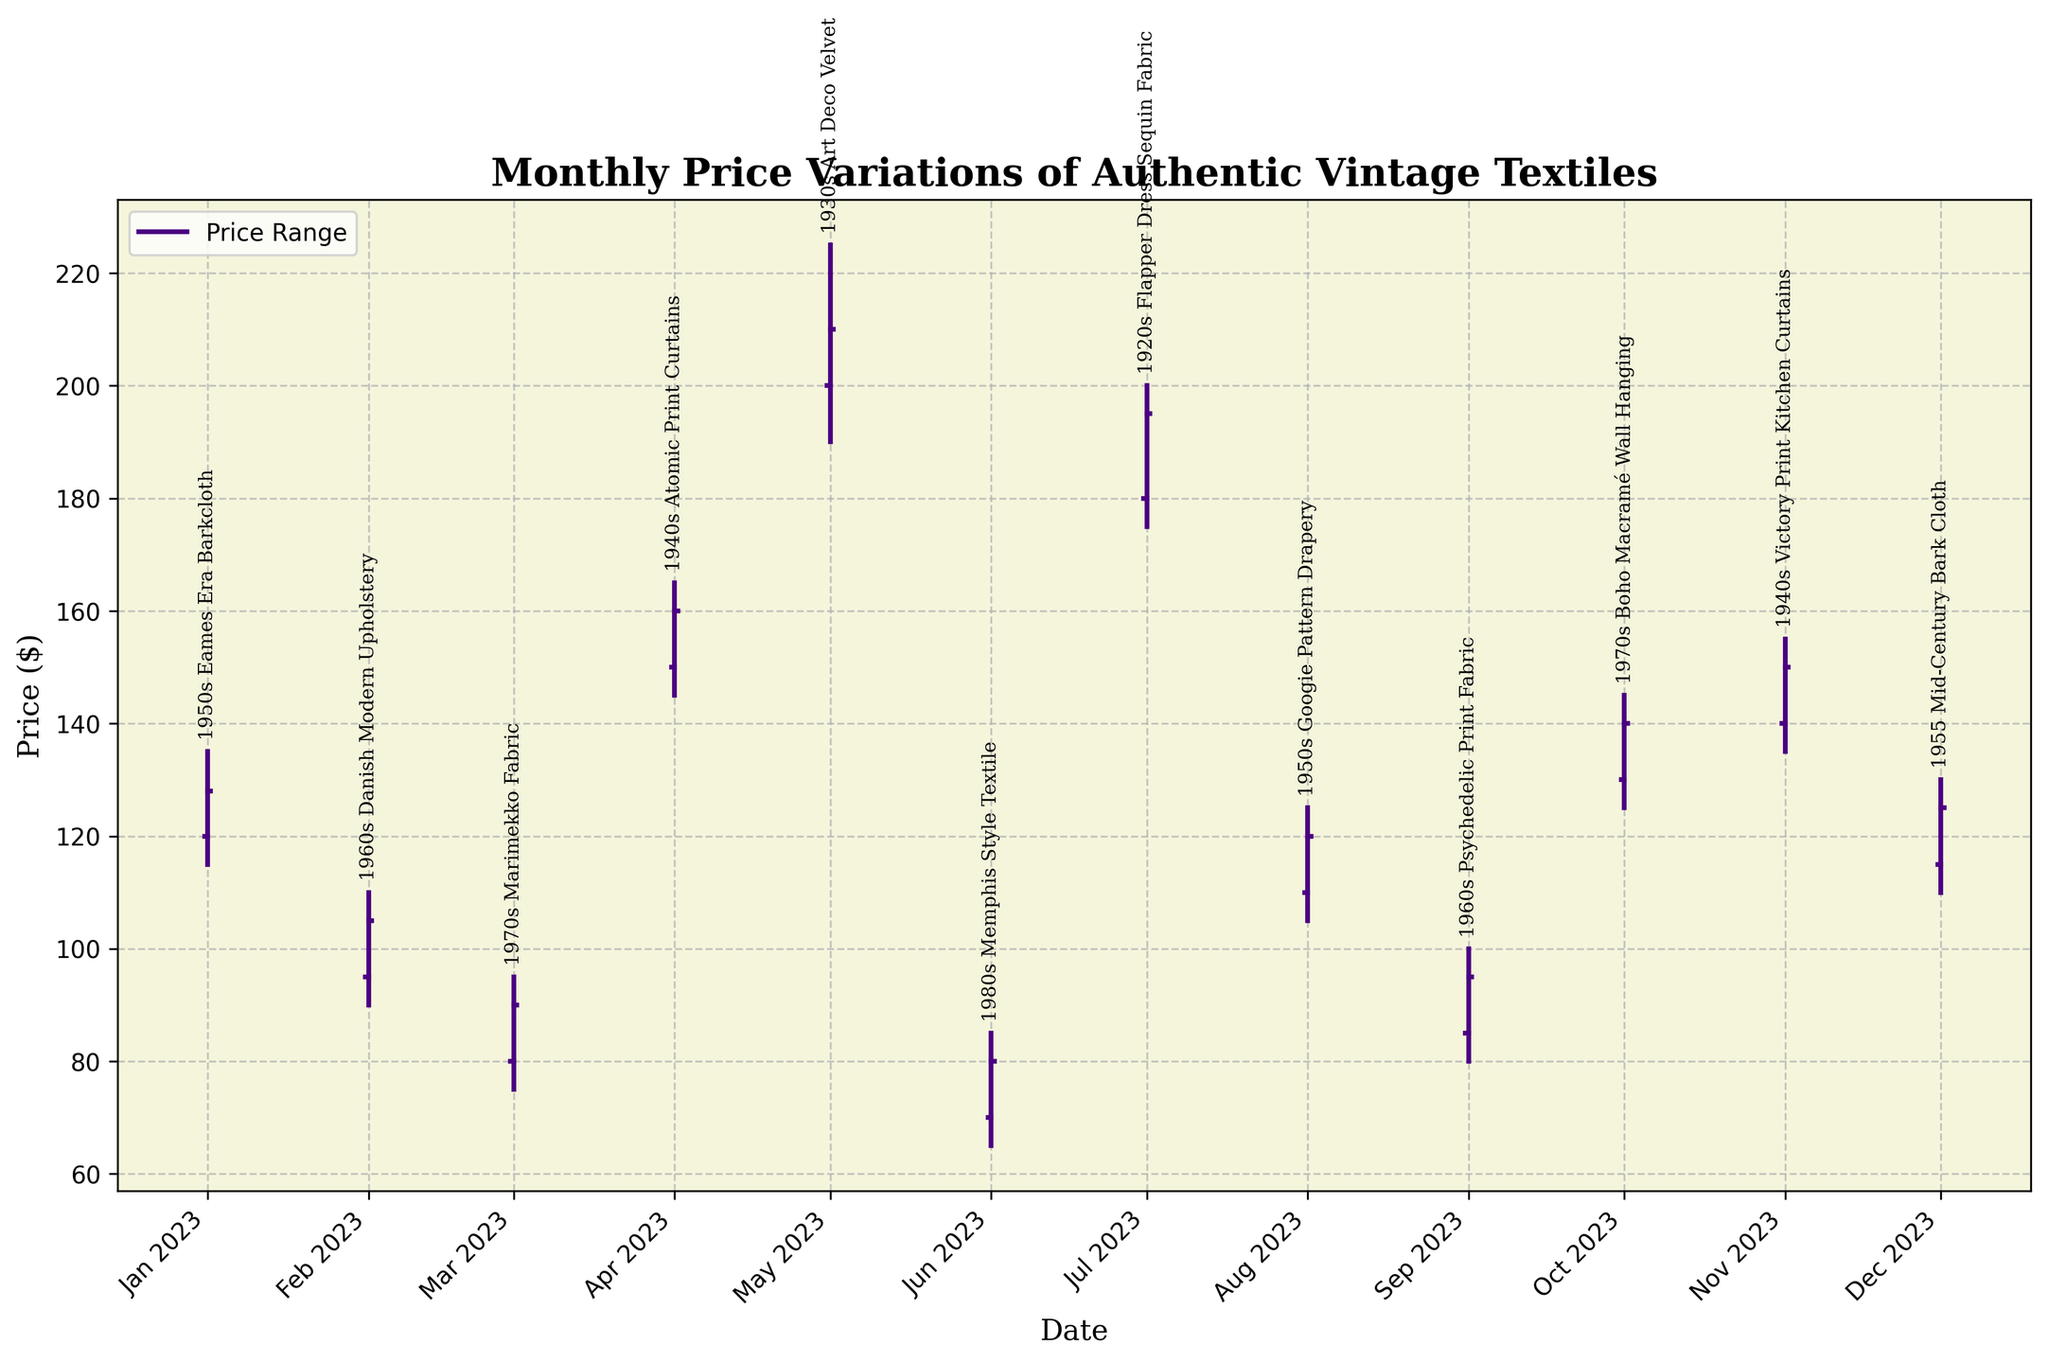What is the title of the chart? The title is usually placed at the top of the chart. In this chart, it read as "Monthly Price Variations of Authentic Vintage Textiles".
Answer: Monthly Price Variations of Authentic Vintage Textiles Which textile has the highest closing price? The textile with the highest closing price can be identified by looking at the Close values along the y-axis. In the chart, the maximum Close value is for the "1930s Art Deco Velvet".
Answer: 1930s Art Deco Velvet What is the price range for "1970s Marimekko Fabric" in March 2023? To find the price range, subtract the Low price from the High price for "1970s Marimekko Fabric" in March 2023. The prices are High: $95, Low: $75, so the range is 95 - 75.
Answer: $20 How many textiles had a closing price above $150? To answer this, count the number of textiles whose Close price is above $150 by observing the Close ticks above $150 on the y-axis. The textiles are "1940s Atomic Print Curtains", "1930s Art Deco Velvet", "1920s Flapper Dress Sequin Fabric", and "1940s Victory Print Kitchen Curtains".
Answer: 4 Which month had the highest volatility, indicated by the largest difference between High and Low prices? Volatility can be measured by the difference between the High and Low prices. The month's volatility is calculated by subtracting Low from High for every month, and the largest difference is found in May 2023 for "1930s Art Deco Velvet" with High: $225, Low: $190. The difference is 225 - 190.
Answer: May 2023 Which textiles' prices increased from open to close in their respective months? Prices increase if the Close price is higher than the Open price. Observing the chart, the textiles that match this criteria are "1950s Eames Era Barkcloth", "1960s Danish Modern Upholstery", "1970s Marimekko Fabric", "1940s Atomic Print Curtains", "1930s Art Deco Velvet", "1980s Memphis Style Textile", "1920s Flapper Dress Sequin Fabric", "1960s Psychedelic Print Fabric", "1970s Boho Macramé Wall Hanging", "1940s Victory Print Kitchen Curtains", and "1955 Mid-Century Bark Cloth".
Answer: 11 textiles For which textile in 2023 did the Close price match exactly with the High price? To find this, compare the Close and High prices for each textile in the chart. The only place where Close equals the High price is for "1940s Atomic Print Curtains" in April 2023.
Answer: 1940s Atomic Print Curtains What month shows the least fluctuation in prices for a textile and what is the textile? Least fluctuation means the smallest difference between High and Low prices. Observing the differences visually in the chart, and the smallest difference is for "1980s Memphis Style Textile" in June 2023 with High: $85 and Low: $65. The difference is 85 - 65.
Answer: June 2023, 1980s Memphis Style Textile Which month saw the price of "1950s Googie Pattern Drapery" at its lowest value? The lowest value for "1950s Googie Pattern Drapery" can be found by looking at the Tick value indicating the Low price for the given month. The Low price is $105 in August 2023.
Answer: August 2023 Which decades are represented in the chart? The chart annotations include the decade information for each textile. Observing the textiles, the decades represented are the 1920s, 1930s, 1940s, 1950s, 1960s, 1970s, and 1980s.
Answer: 7 decades 